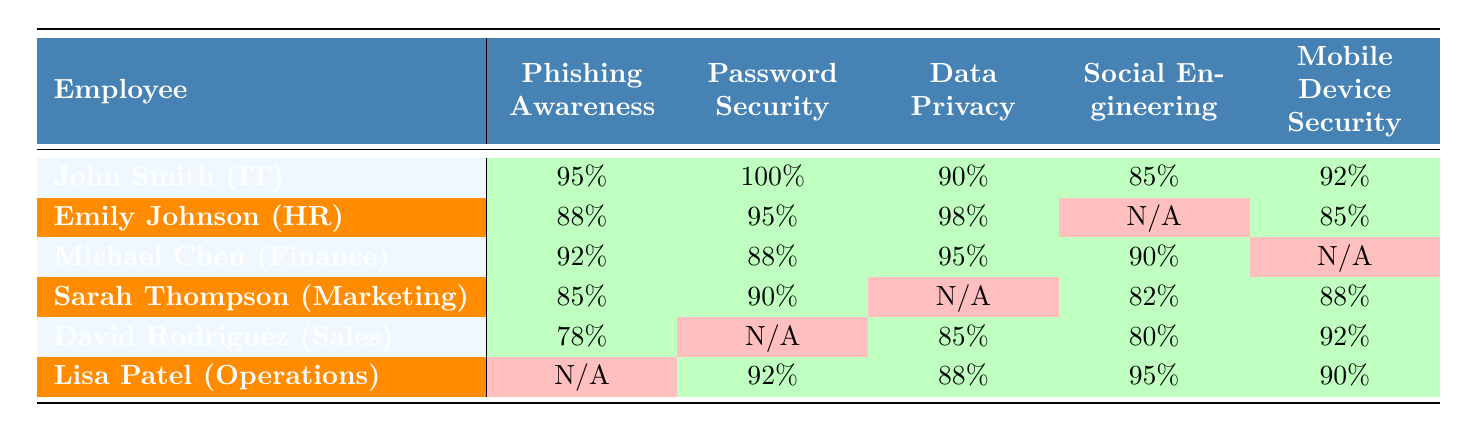What is the completion rate for phishing awareness training among employees? All employees listed in the table completed the phishing awareness training, as indicated by the 'true' values in that column for each employee.
Answer: 100% Which employee scored the highest in password security? Looking at the 'Password Security' scores, John Smith scored 100%, which is the highest among all employees listed.
Answer: John Smith How many employees completed the social engineering training? The employees who completed social engineering training are Emily Johnson, Michael Chen, Sarah Thompson, and David Rodriguez, totaling four employees.
Answer: 4 What is the average score for mobile device security across all employees? The mobile device security scores are 92, 85, N/A, 88, 92, and 90. Ignoring the N/A, the sum is (92 + 85 + 88 + 92 + 90) = 447. There are 5 scores, so the average is 447/5 = 89.4.
Answer: 89.4 Did Lisa Patel complete all training modules? Lisa Patel did not complete the phishing awareness training, as indicated by the 'false' value in that column.
Answer: No Which department has the highest average score in data privacy training? The scores for data privacy are 90, 98, 95, N/A, 85, and 88. Ignoring the N/A, the sum is (90 + 98 + 95 + 85 + 88) = 456, and there are 5 scores, so the average is 456/5 = 91.2. The IT, HR, Finance, and Operations departments have scores in data privacy; averaging these results gives HR the highest average at 98.
Answer: HR How many training modules did Michael Chen complete? Michael Chen completed the phishing awareness, password security, data privacy, and social engineering training modules, totaling four modules.
Answer: 4 Is there any employee who did not complete password security training? David Rodriguez did not complete password security training, as indicated by the 'false' value in that column.
Answer: Yes What is the lowest score achieved in social engineering training? In the social engineering training module, Sarah Thompson scored 82, which is the lowest among all employees.
Answer: 82 What percentage of employees completed the data privacy training? Five out of six employees completed the data privacy training, resulting in a completion rate of (5/6) x 100% = 83.33%.
Answer: 83.33% 